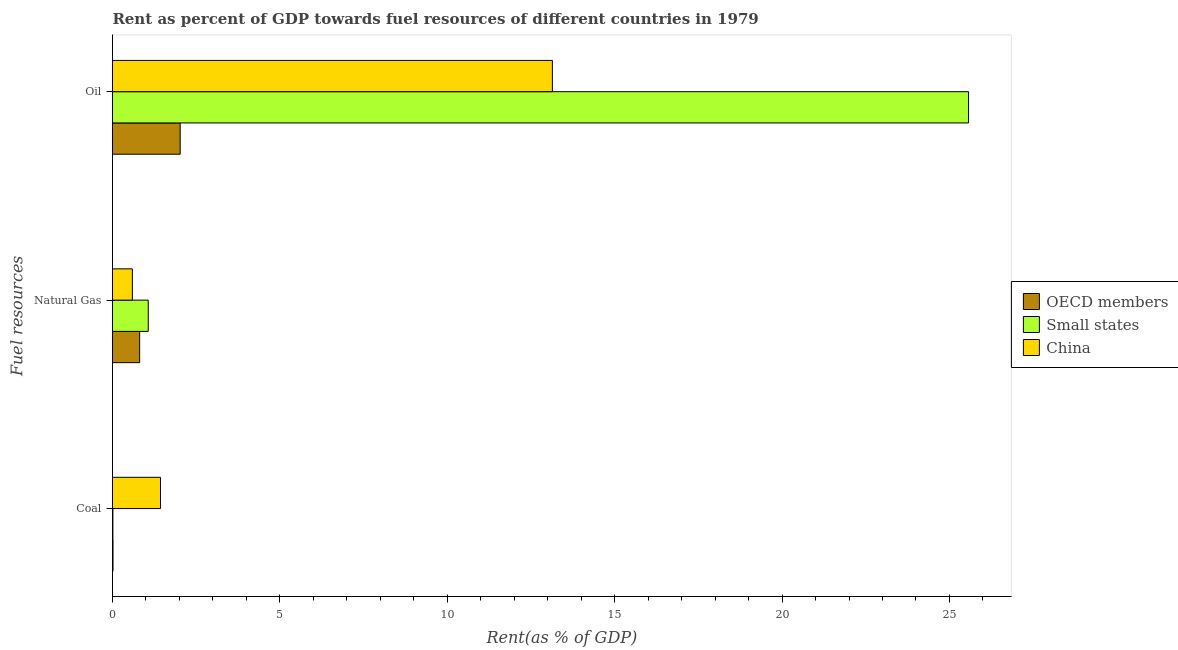How many groups of bars are there?
Provide a short and direct response. 3. Are the number of bars on each tick of the Y-axis equal?
Make the answer very short. Yes. How many bars are there on the 2nd tick from the top?
Give a very brief answer. 3. What is the label of the 3rd group of bars from the top?
Your answer should be compact. Coal. What is the rent towards natural gas in OECD members?
Your answer should be compact. 0.81. Across all countries, what is the maximum rent towards oil?
Provide a succinct answer. 25.57. Across all countries, what is the minimum rent towards oil?
Give a very brief answer. 2.02. In which country was the rent towards oil minimum?
Your answer should be compact. OECD members. What is the total rent towards coal in the graph?
Your answer should be compact. 1.46. What is the difference between the rent towards oil in OECD members and that in Small states?
Provide a succinct answer. -23.55. What is the difference between the rent towards oil in Small states and the rent towards coal in OECD members?
Your response must be concise. 25.56. What is the average rent towards natural gas per country?
Make the answer very short. 0.82. What is the difference between the rent towards coal and rent towards oil in Small states?
Your response must be concise. -25.56. In how many countries, is the rent towards oil greater than 24 %?
Provide a short and direct response. 1. What is the ratio of the rent towards natural gas in OECD members to that in China?
Keep it short and to the point. 1.37. Is the difference between the rent towards coal in China and Small states greater than the difference between the rent towards oil in China and Small states?
Make the answer very short. Yes. What is the difference between the highest and the second highest rent towards natural gas?
Your answer should be compact. 0.26. What is the difference between the highest and the lowest rent towards coal?
Your answer should be compact. 1.42. Is the sum of the rent towards natural gas in OECD members and Small states greater than the maximum rent towards oil across all countries?
Provide a short and direct response. No. What is the difference between two consecutive major ticks on the X-axis?
Provide a succinct answer. 5. Does the graph contain any zero values?
Your response must be concise. No. How many legend labels are there?
Your answer should be compact. 3. What is the title of the graph?
Offer a very short reply. Rent as percent of GDP towards fuel resources of different countries in 1979. Does "Russian Federation" appear as one of the legend labels in the graph?
Your answer should be very brief. No. What is the label or title of the X-axis?
Ensure brevity in your answer.  Rent(as % of GDP). What is the label or title of the Y-axis?
Ensure brevity in your answer.  Fuel resources. What is the Rent(as % of GDP) of OECD members in Coal?
Offer a very short reply. 0.02. What is the Rent(as % of GDP) in Small states in Coal?
Offer a very short reply. 0.01. What is the Rent(as % of GDP) in China in Coal?
Your response must be concise. 1.43. What is the Rent(as % of GDP) in OECD members in Natural Gas?
Your answer should be compact. 0.81. What is the Rent(as % of GDP) in Small states in Natural Gas?
Give a very brief answer. 1.07. What is the Rent(as % of GDP) of China in Natural Gas?
Your answer should be compact. 0.59. What is the Rent(as % of GDP) in OECD members in Oil?
Make the answer very short. 2.02. What is the Rent(as % of GDP) in Small states in Oil?
Offer a terse response. 25.57. What is the Rent(as % of GDP) of China in Oil?
Your answer should be compact. 13.14. Across all Fuel resources, what is the maximum Rent(as % of GDP) of OECD members?
Provide a short and direct response. 2.02. Across all Fuel resources, what is the maximum Rent(as % of GDP) in Small states?
Make the answer very short. 25.57. Across all Fuel resources, what is the maximum Rent(as % of GDP) of China?
Offer a very short reply. 13.14. Across all Fuel resources, what is the minimum Rent(as % of GDP) in OECD members?
Ensure brevity in your answer.  0.02. Across all Fuel resources, what is the minimum Rent(as % of GDP) of Small states?
Make the answer very short. 0.01. Across all Fuel resources, what is the minimum Rent(as % of GDP) of China?
Provide a succinct answer. 0.59. What is the total Rent(as % of GDP) of OECD members in the graph?
Make the answer very short. 2.85. What is the total Rent(as % of GDP) in Small states in the graph?
Offer a terse response. 26.65. What is the total Rent(as % of GDP) in China in the graph?
Give a very brief answer. 15.17. What is the difference between the Rent(as % of GDP) in OECD members in Coal and that in Natural Gas?
Your answer should be compact. -0.8. What is the difference between the Rent(as % of GDP) of Small states in Coal and that in Natural Gas?
Your response must be concise. -1.06. What is the difference between the Rent(as % of GDP) of China in Coal and that in Natural Gas?
Provide a short and direct response. 0.84. What is the difference between the Rent(as % of GDP) in OECD members in Coal and that in Oil?
Provide a short and direct response. -2.01. What is the difference between the Rent(as % of GDP) in Small states in Coal and that in Oil?
Offer a terse response. -25.56. What is the difference between the Rent(as % of GDP) of China in Coal and that in Oil?
Ensure brevity in your answer.  -11.7. What is the difference between the Rent(as % of GDP) of OECD members in Natural Gas and that in Oil?
Provide a succinct answer. -1.21. What is the difference between the Rent(as % of GDP) of Small states in Natural Gas and that in Oil?
Offer a terse response. -24.5. What is the difference between the Rent(as % of GDP) of China in Natural Gas and that in Oil?
Your answer should be compact. -12.55. What is the difference between the Rent(as % of GDP) in OECD members in Coal and the Rent(as % of GDP) in Small states in Natural Gas?
Your response must be concise. -1.05. What is the difference between the Rent(as % of GDP) in OECD members in Coal and the Rent(as % of GDP) in China in Natural Gas?
Offer a very short reply. -0.58. What is the difference between the Rent(as % of GDP) of Small states in Coal and the Rent(as % of GDP) of China in Natural Gas?
Your answer should be compact. -0.58. What is the difference between the Rent(as % of GDP) in OECD members in Coal and the Rent(as % of GDP) in Small states in Oil?
Keep it short and to the point. -25.56. What is the difference between the Rent(as % of GDP) of OECD members in Coal and the Rent(as % of GDP) of China in Oil?
Your answer should be very brief. -13.12. What is the difference between the Rent(as % of GDP) in Small states in Coal and the Rent(as % of GDP) in China in Oil?
Provide a short and direct response. -13.13. What is the difference between the Rent(as % of GDP) in OECD members in Natural Gas and the Rent(as % of GDP) in Small states in Oil?
Your answer should be compact. -24.76. What is the difference between the Rent(as % of GDP) of OECD members in Natural Gas and the Rent(as % of GDP) of China in Oil?
Your answer should be compact. -12.33. What is the difference between the Rent(as % of GDP) of Small states in Natural Gas and the Rent(as % of GDP) of China in Oil?
Your answer should be very brief. -12.07. What is the average Rent(as % of GDP) of OECD members per Fuel resources?
Your answer should be very brief. 0.95. What is the average Rent(as % of GDP) in Small states per Fuel resources?
Provide a succinct answer. 8.88. What is the average Rent(as % of GDP) of China per Fuel resources?
Offer a very short reply. 5.06. What is the difference between the Rent(as % of GDP) in OECD members and Rent(as % of GDP) in Small states in Coal?
Offer a very short reply. 0. What is the difference between the Rent(as % of GDP) of OECD members and Rent(as % of GDP) of China in Coal?
Offer a very short reply. -1.42. What is the difference between the Rent(as % of GDP) in Small states and Rent(as % of GDP) in China in Coal?
Ensure brevity in your answer.  -1.42. What is the difference between the Rent(as % of GDP) in OECD members and Rent(as % of GDP) in Small states in Natural Gas?
Your response must be concise. -0.26. What is the difference between the Rent(as % of GDP) in OECD members and Rent(as % of GDP) in China in Natural Gas?
Your answer should be very brief. 0.22. What is the difference between the Rent(as % of GDP) in Small states and Rent(as % of GDP) in China in Natural Gas?
Provide a short and direct response. 0.47. What is the difference between the Rent(as % of GDP) of OECD members and Rent(as % of GDP) of Small states in Oil?
Give a very brief answer. -23.55. What is the difference between the Rent(as % of GDP) in OECD members and Rent(as % of GDP) in China in Oil?
Make the answer very short. -11.12. What is the difference between the Rent(as % of GDP) of Small states and Rent(as % of GDP) of China in Oil?
Your answer should be very brief. 12.43. What is the ratio of the Rent(as % of GDP) in OECD members in Coal to that in Natural Gas?
Your answer should be very brief. 0.02. What is the ratio of the Rent(as % of GDP) in Small states in Coal to that in Natural Gas?
Offer a very short reply. 0.01. What is the ratio of the Rent(as % of GDP) of China in Coal to that in Natural Gas?
Make the answer very short. 2.42. What is the ratio of the Rent(as % of GDP) of OECD members in Coal to that in Oil?
Make the answer very short. 0.01. What is the ratio of the Rent(as % of GDP) in Small states in Coal to that in Oil?
Offer a terse response. 0. What is the ratio of the Rent(as % of GDP) in China in Coal to that in Oil?
Give a very brief answer. 0.11. What is the ratio of the Rent(as % of GDP) in OECD members in Natural Gas to that in Oil?
Your response must be concise. 0.4. What is the ratio of the Rent(as % of GDP) of Small states in Natural Gas to that in Oil?
Your answer should be very brief. 0.04. What is the ratio of the Rent(as % of GDP) in China in Natural Gas to that in Oil?
Offer a very short reply. 0.05. What is the difference between the highest and the second highest Rent(as % of GDP) in OECD members?
Make the answer very short. 1.21. What is the difference between the highest and the second highest Rent(as % of GDP) of Small states?
Give a very brief answer. 24.5. What is the difference between the highest and the second highest Rent(as % of GDP) in China?
Give a very brief answer. 11.7. What is the difference between the highest and the lowest Rent(as % of GDP) of OECD members?
Your answer should be very brief. 2.01. What is the difference between the highest and the lowest Rent(as % of GDP) in Small states?
Give a very brief answer. 25.56. What is the difference between the highest and the lowest Rent(as % of GDP) of China?
Ensure brevity in your answer.  12.55. 